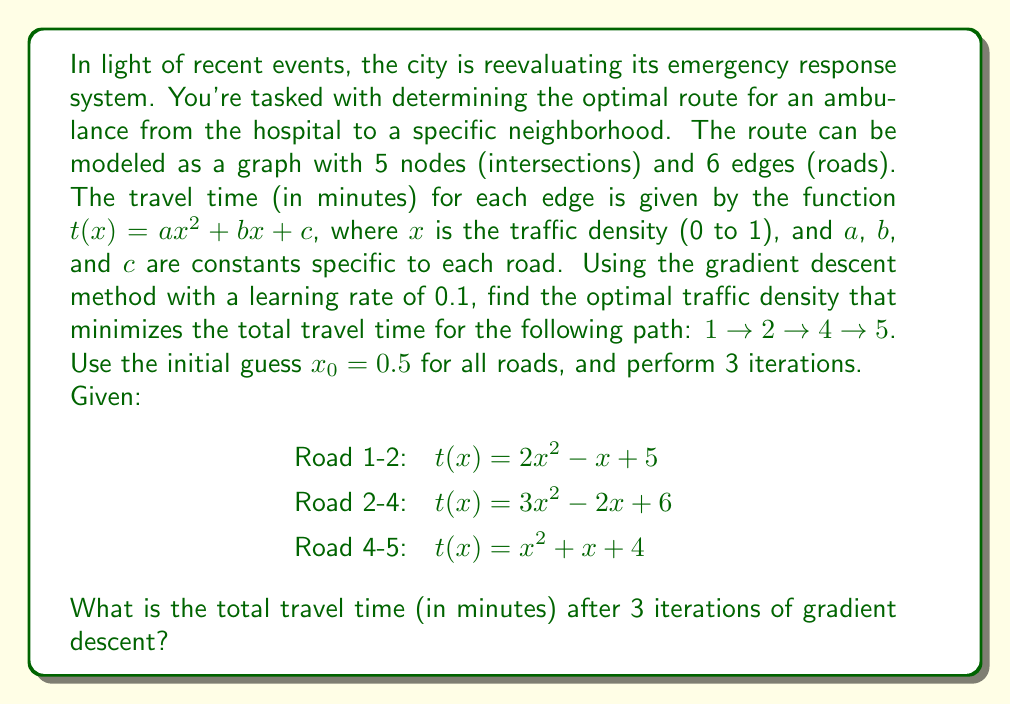Show me your answer to this math problem. Let's solve this step-by-step using the gradient descent method:

1) First, we need to define our objective function, which is the sum of travel times for all roads:

   $$f(x) = (2x^2 - x + 5) + (3x^2 - 2x + 6) + (x^2 + x + 4)$$
   $$f(x) = 6x^2 - 2x + 15$$

2) The gradient of this function is:

   $$f'(x) = 12x - 2$$

3) The gradient descent update rule is:

   $$x_{n+1} = x_n - \alpha f'(x_n)$$

   where $\alpha = 0.1$ is the learning rate.

4) Now, let's perform 3 iterations:

   Iteration 1:
   $$x_1 = 0.5 - 0.1(12(0.5) - 2) = 0.5 - 0.1(4) = 0.1$$

   Iteration 2:
   $$x_2 = 0.1 - 0.1(12(0.1) - 2) = 0.1 - 0.1(-0.8) = 0.18$$

   Iteration 3:
   $$x_3 = 0.18 - 0.1(12(0.18) - 2) = 0.18 - 0.1(0.16) = 0.1784$$

5) Now, we can calculate the total travel time using $x = 0.1784$:

   $$f(0.1784) = 6(0.1784)^2 - 2(0.1784) + 15$$
   $$= 0.1910 - 0.3568 + 15$$
   $$= 14.8342$$

Therefore, the total travel time after 3 iterations of gradient descent is approximately 14.8342 minutes.
Answer: 14.8342 minutes 